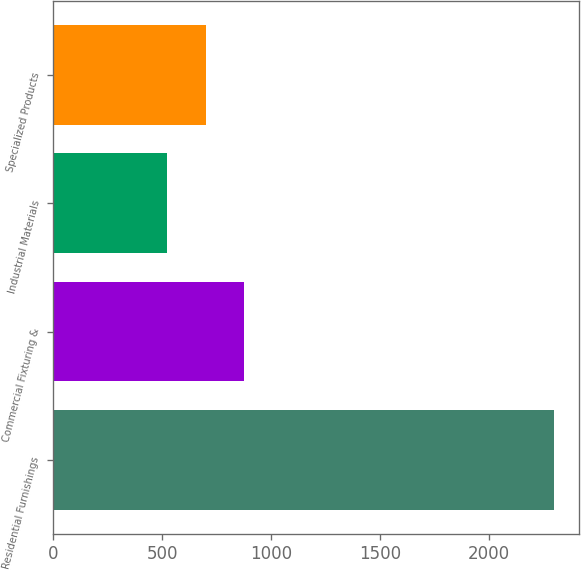<chart> <loc_0><loc_0><loc_500><loc_500><bar_chart><fcel>Residential Furnishings<fcel>Commercial Fixturing &<fcel>Industrial Materials<fcel>Specialized Products<nl><fcel>2294.8<fcel>877.44<fcel>523.1<fcel>700.27<nl></chart> 